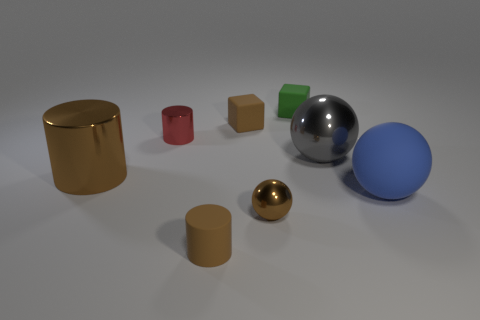Subtract all blue cubes. Subtract all yellow cylinders. How many cubes are left? 2 Add 2 green cylinders. How many objects exist? 10 Subtract all cylinders. How many objects are left? 5 Subtract all big purple cylinders. Subtract all big metallic objects. How many objects are left? 6 Add 6 tiny red shiny cylinders. How many tiny red shiny cylinders are left? 7 Add 8 big blue things. How many big blue things exist? 9 Subtract 0 purple spheres. How many objects are left? 8 